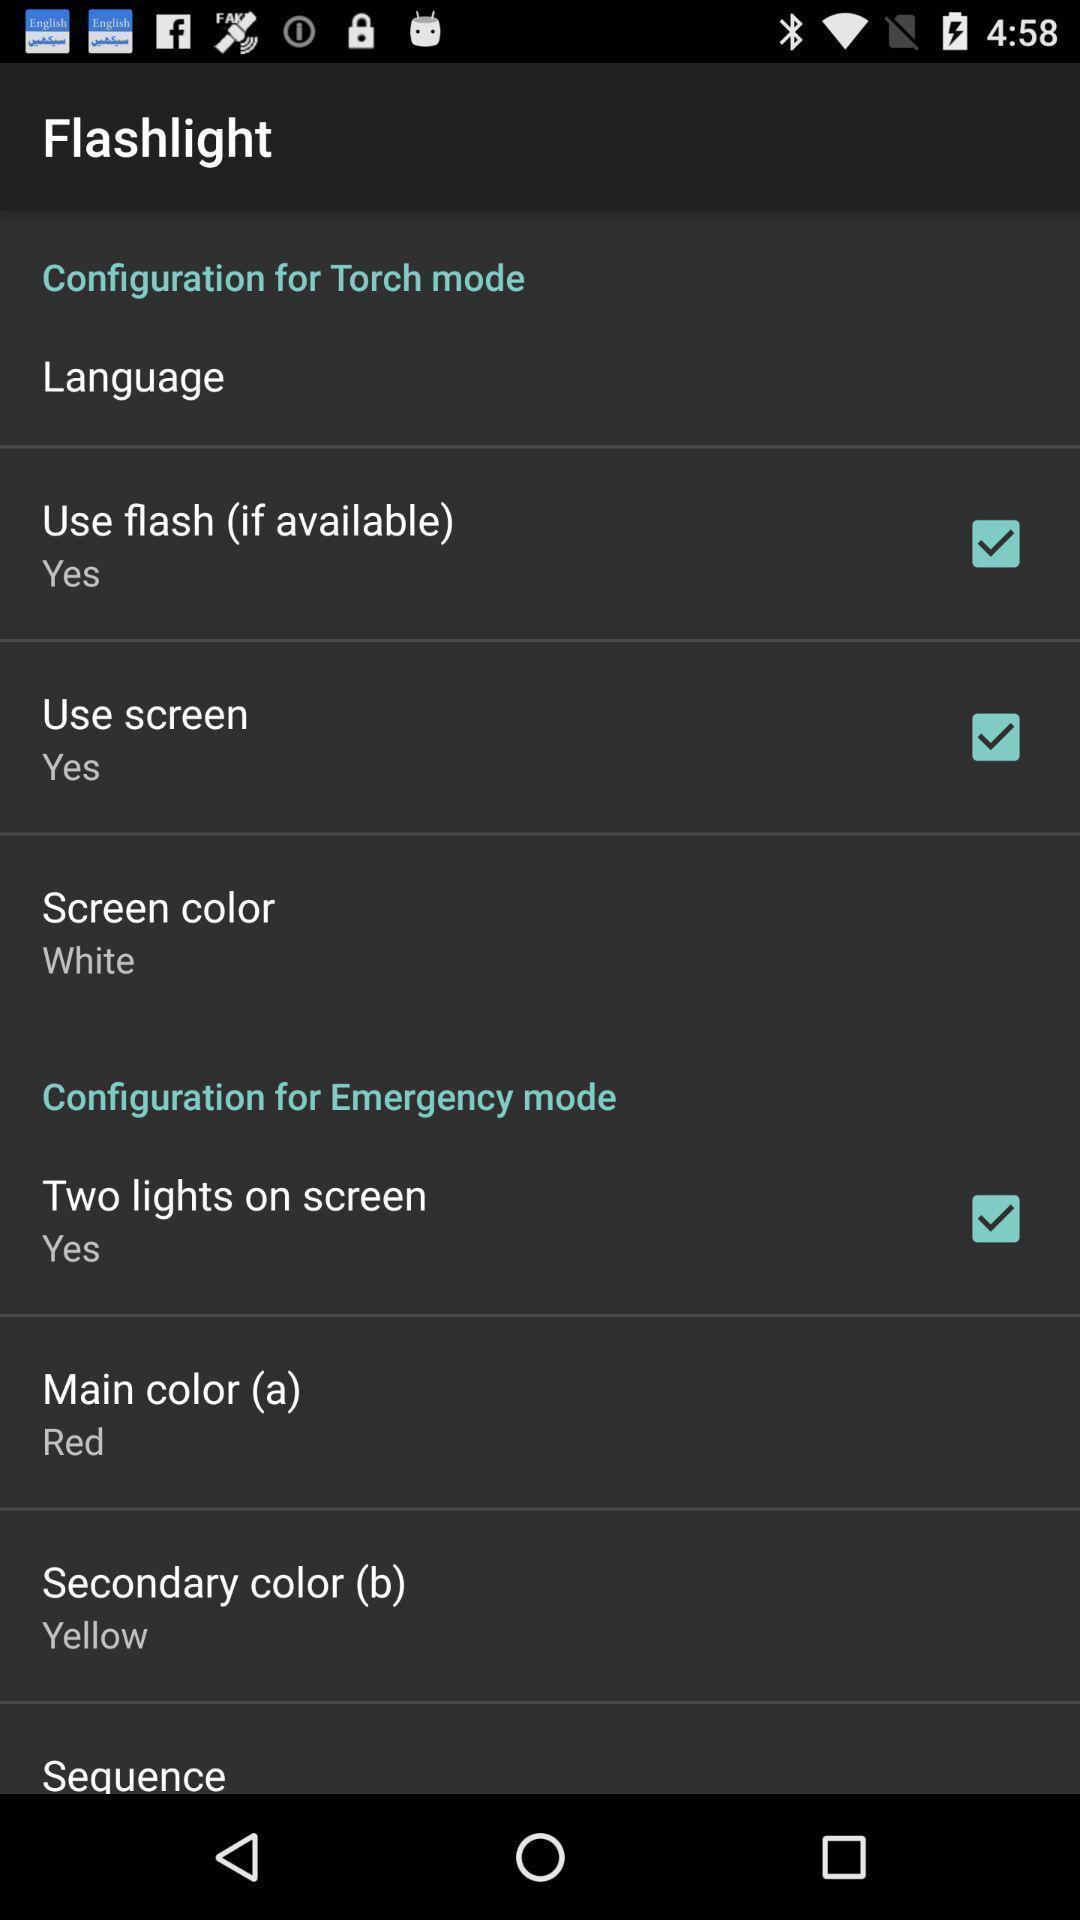What details can you identify in this image? Settings page with different options in the flashlight app. 